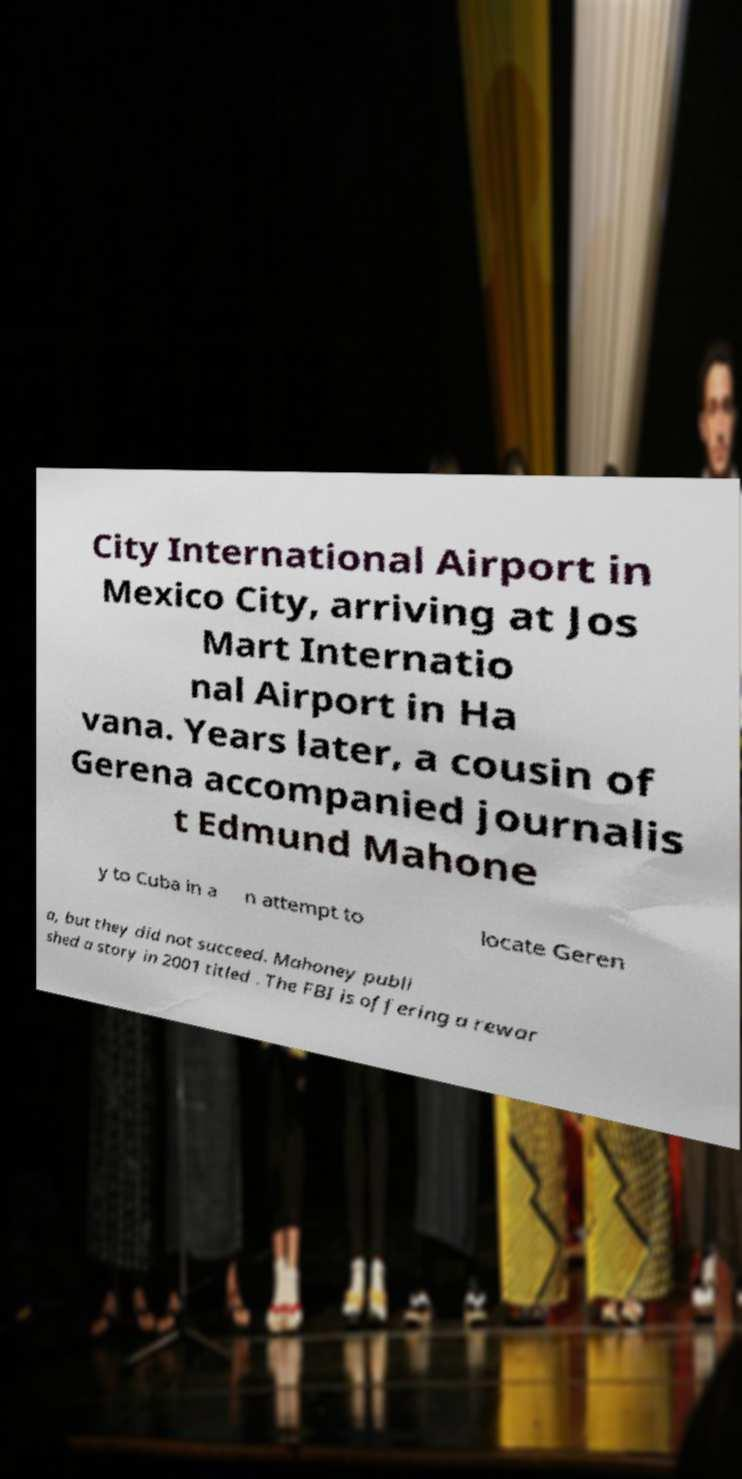What messages or text are displayed in this image? I need them in a readable, typed format. City International Airport in Mexico City, arriving at Jos Mart Internatio nal Airport in Ha vana. Years later, a cousin of Gerena accompanied journalis t Edmund Mahone y to Cuba in a n attempt to locate Geren a, but they did not succeed. Mahoney publi shed a story in 2001 titled . The FBI is offering a rewar 